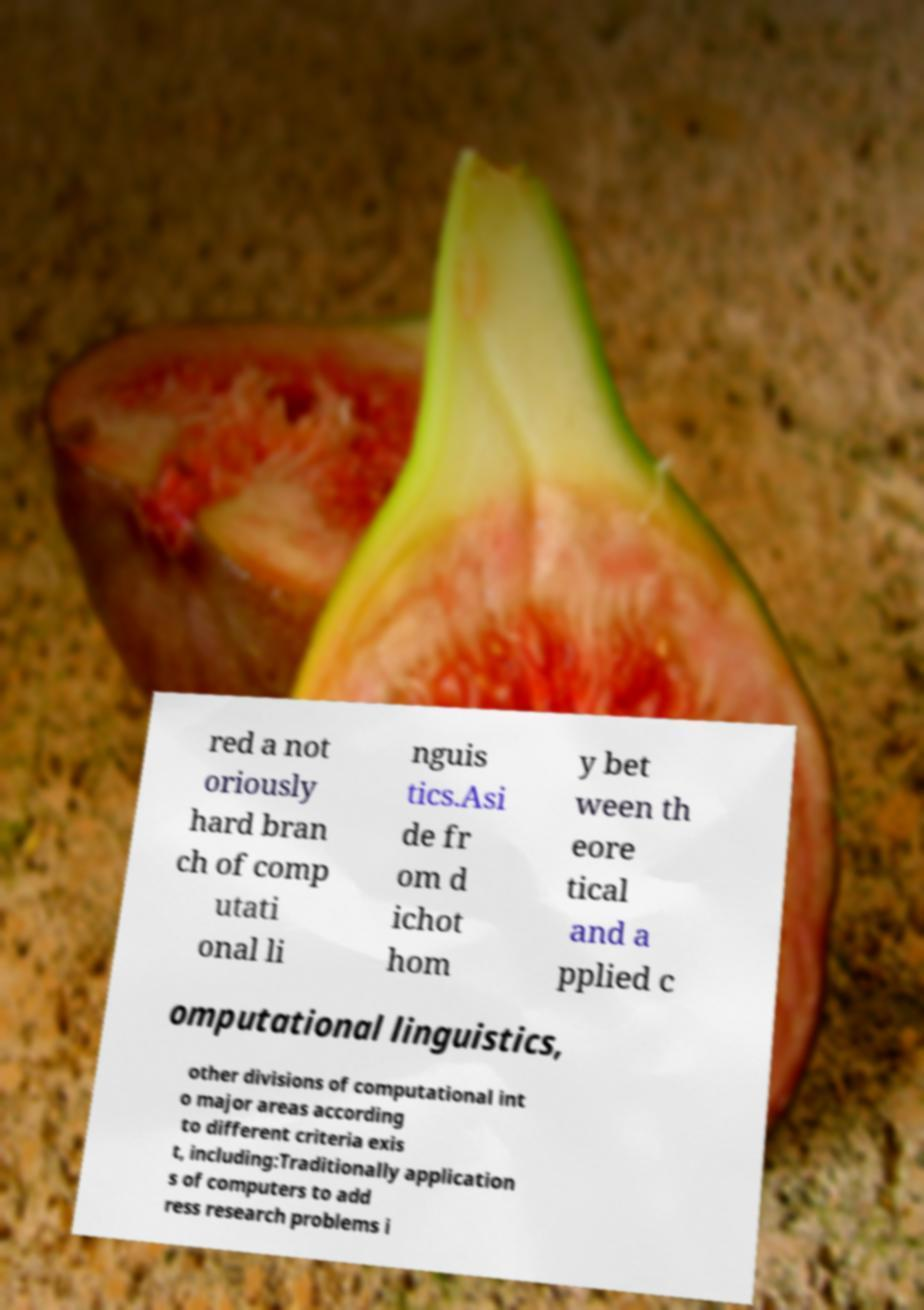Please read and relay the text visible in this image. What does it say? red a not oriously hard bran ch of comp utati onal li nguis tics.Asi de fr om d ichot hom y bet ween th eore tical and a pplied c omputational linguistics, other divisions of computational int o major areas according to different criteria exis t, including:Traditionally application s of computers to add ress research problems i 